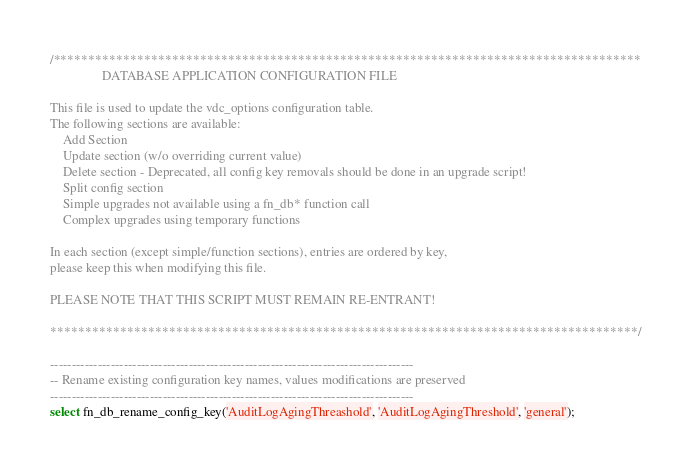Convert code to text. <code><loc_0><loc_0><loc_500><loc_500><_SQL_>/************************************************************************************
                DATABASE APPLICATION CONFIGURATION FILE

This file is used to update the vdc_options configuration table.
The following sections are available:
    Add Section
    Update section (w/o overriding current value)
    Delete section - Deprecated, all config key removals should be done in an upgrade script!
    Split config section
    Simple upgrades not available using a fn_db* function call
    Complex upgrades using temporary functions

In each section (except simple/function sections), entries are ordered by key,
please keep this when modifying this file.

PLEASE NOTE THAT THIS SCRIPT MUST REMAIN RE-ENTRANT!

************************************************************************************/

------------------------------------------------------------------------------------
-- Rename existing configuration key names, values modifications are preserved
------------------------------------------------------------------------------------
select fn_db_rename_config_key('AuditLogAgingThreashold', 'AuditLogAgingThreshold', 'general');</code> 